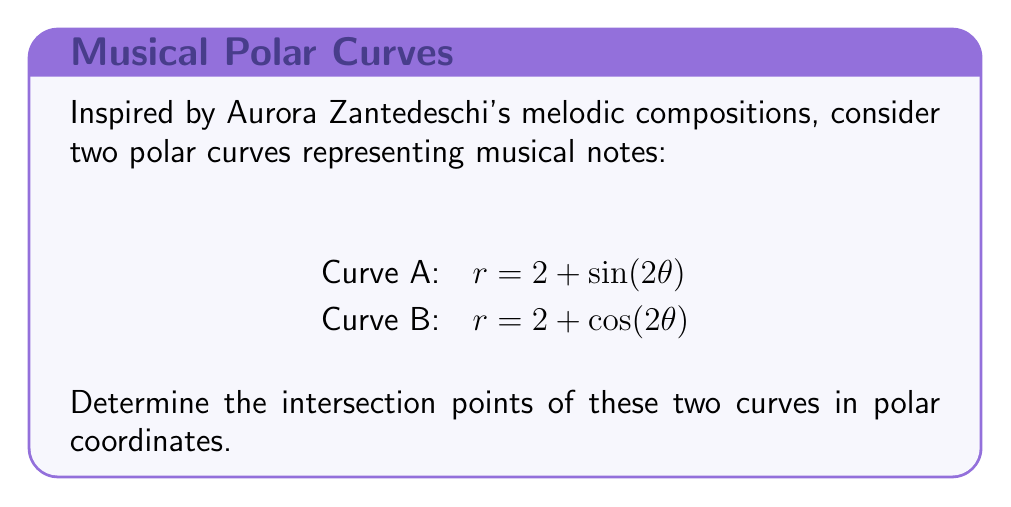Show me your answer to this math problem. To find the intersection points, we need to solve the equation where both curves have the same $r$ and $\theta$ values:

1) Set the equations equal to each other:
   $2 + \sin(2\theta) = 2 + \cos(2\theta)$

2) Simplify:
   $\sin(2\theta) = \cos(2\theta)$

3) Divide both sides by $\cos(2\theta)$ (assuming $\cos(2\theta) \neq 0$):
   $\tan(2\theta) = 1$

4) Solve for $\theta$:
   $2\theta = \arctan(1) = \frac{\pi}{4}$ (in the first quadrant)
   $\theta = \frac{\pi}{8}$ (first solution)

   Due to periodicity, we also have:
   $\theta = \frac{\pi}{8} + \frac{\pi}{2} = \frac{5\pi}{8}$ (second solution)

5) Find $r$ for each $\theta$:
   For $\theta = \frac{\pi}{8}$:
   $r = 2 + \sin(\frac{\pi}{4}) = 2 + \frac{\sqrt{2}}{2} = 2 + \frac{1}{\sqrt{2}}$

   For $\theta = \frac{5\pi}{8}$:
   $r = 2 + \sin(\frac{5\pi}{4}) = 2 - \frac{\sqrt{2}}{2} = 2 - \frac{1}{\sqrt{2}}$

Therefore, the intersection points are:
$(\frac{\pi}{8}, 2 + \frac{1}{\sqrt{2}})$ and $(\frac{5\pi}{8}, 2 - \frac{1}{\sqrt{2}})$

[asy]
import graph;
size(200);
real f(real t) {return 2+sin(2*t);}
real g(real t) {return 2+cos(2*t);}
draw(polargraph(f,0,2pi,operator ..),blue);
draw(polargraph(g,0,2pi,operator ..),red);
dot((pi/8,2+1/sqrt(2)),darkgreen);
dot((5pi/8,2-1/sqrt(2)),darkgreen);
label("A",(2.5,0.5),blue);
label("B",(0.5,2.5),red);
[/asy]
Answer: The intersection points are $(\frac{\pi}{8}, 2 + \frac{1}{\sqrt{2}})$ and $(\frac{5\pi}{8}, 2 - \frac{1}{\sqrt{2}})$ in polar coordinates. 